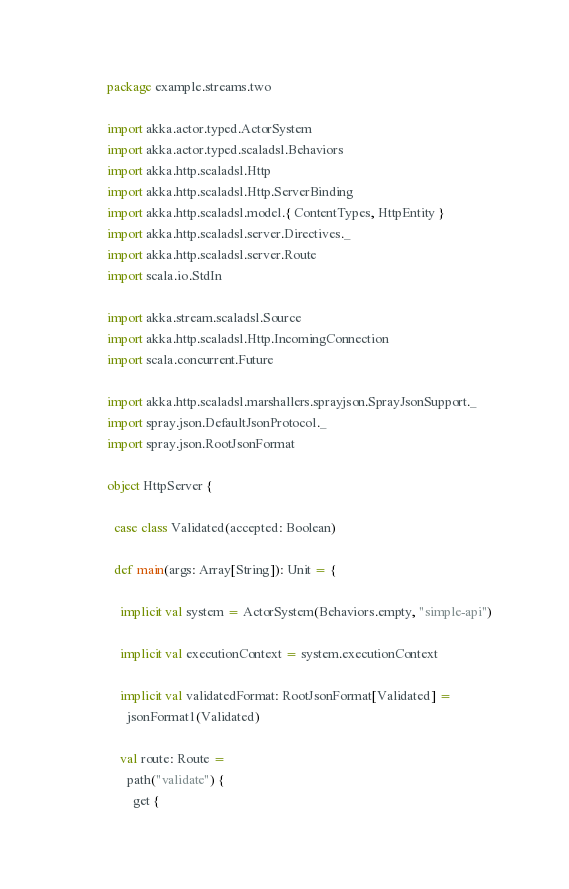<code> <loc_0><loc_0><loc_500><loc_500><_Scala_>package example.streams.two

import akka.actor.typed.ActorSystem
import akka.actor.typed.scaladsl.Behaviors
import akka.http.scaladsl.Http
import akka.http.scaladsl.Http.ServerBinding
import akka.http.scaladsl.model.{ ContentTypes, HttpEntity }
import akka.http.scaladsl.server.Directives._
import akka.http.scaladsl.server.Route
import scala.io.StdIn

import akka.stream.scaladsl.Source
import akka.http.scaladsl.Http.IncomingConnection
import scala.concurrent.Future

import akka.http.scaladsl.marshallers.sprayjson.SprayJsonSupport._
import spray.json.DefaultJsonProtocol._
import spray.json.RootJsonFormat

object HttpServer {

  case class Validated(accepted: Boolean)

  def main(args: Array[String]): Unit = {

    implicit val system = ActorSystem(Behaviors.empty, "simple-api")

    implicit val executionContext = system.executionContext

    implicit val validatedFormat: RootJsonFormat[Validated] =
      jsonFormat1(Validated)

    val route: Route =
      path("validate") {
        get {</code> 